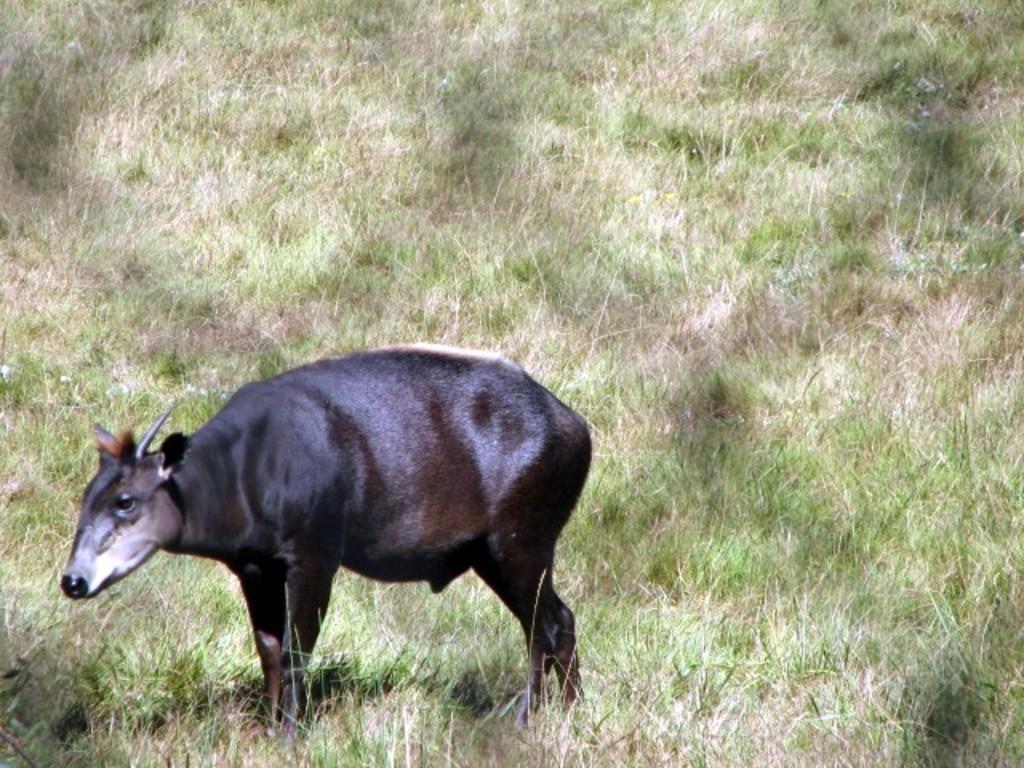Can you describe this image briefly? In this image we can see an animal and in the background we can see the grass. 